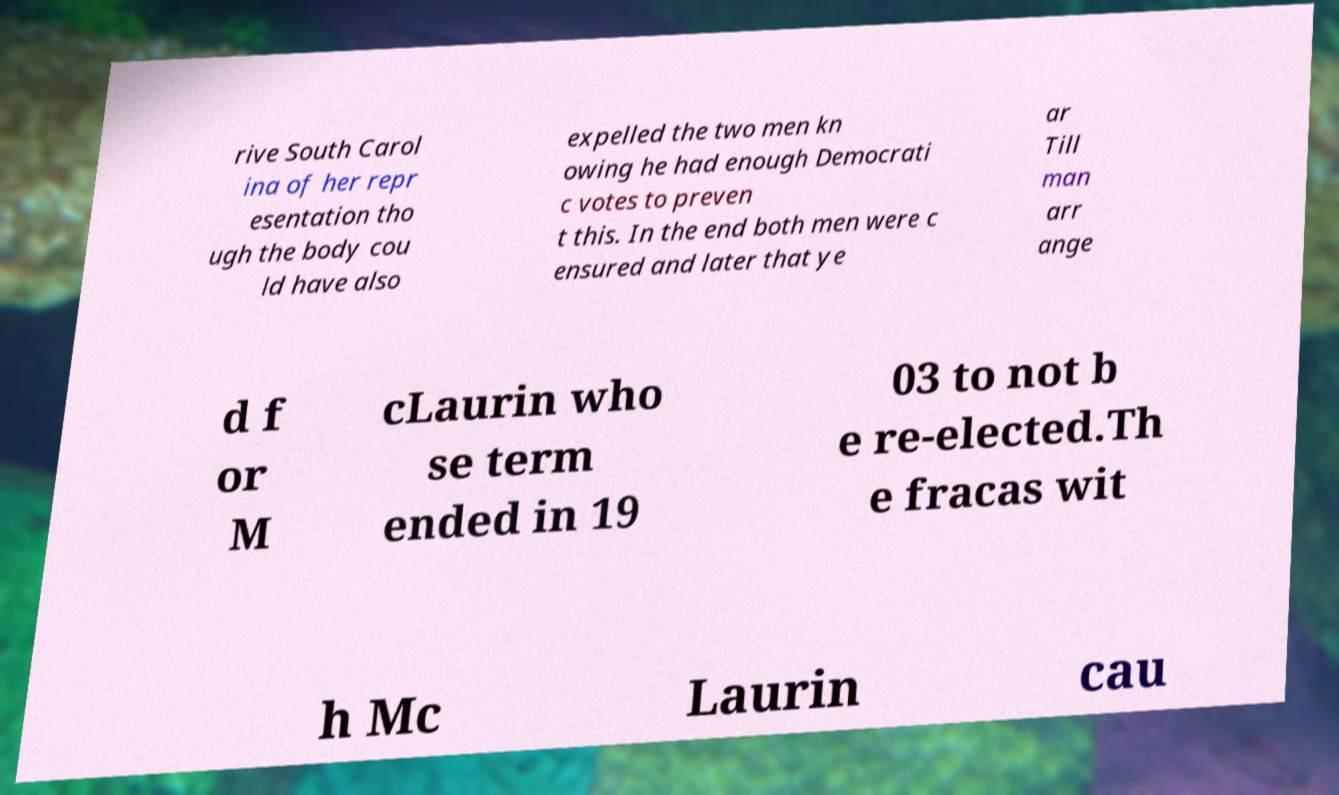I need the written content from this picture converted into text. Can you do that? rive South Carol ina of her repr esentation tho ugh the body cou ld have also expelled the two men kn owing he had enough Democrati c votes to preven t this. In the end both men were c ensured and later that ye ar Till man arr ange d f or M cLaurin who se term ended in 19 03 to not b e re-elected.Th e fracas wit h Mc Laurin cau 